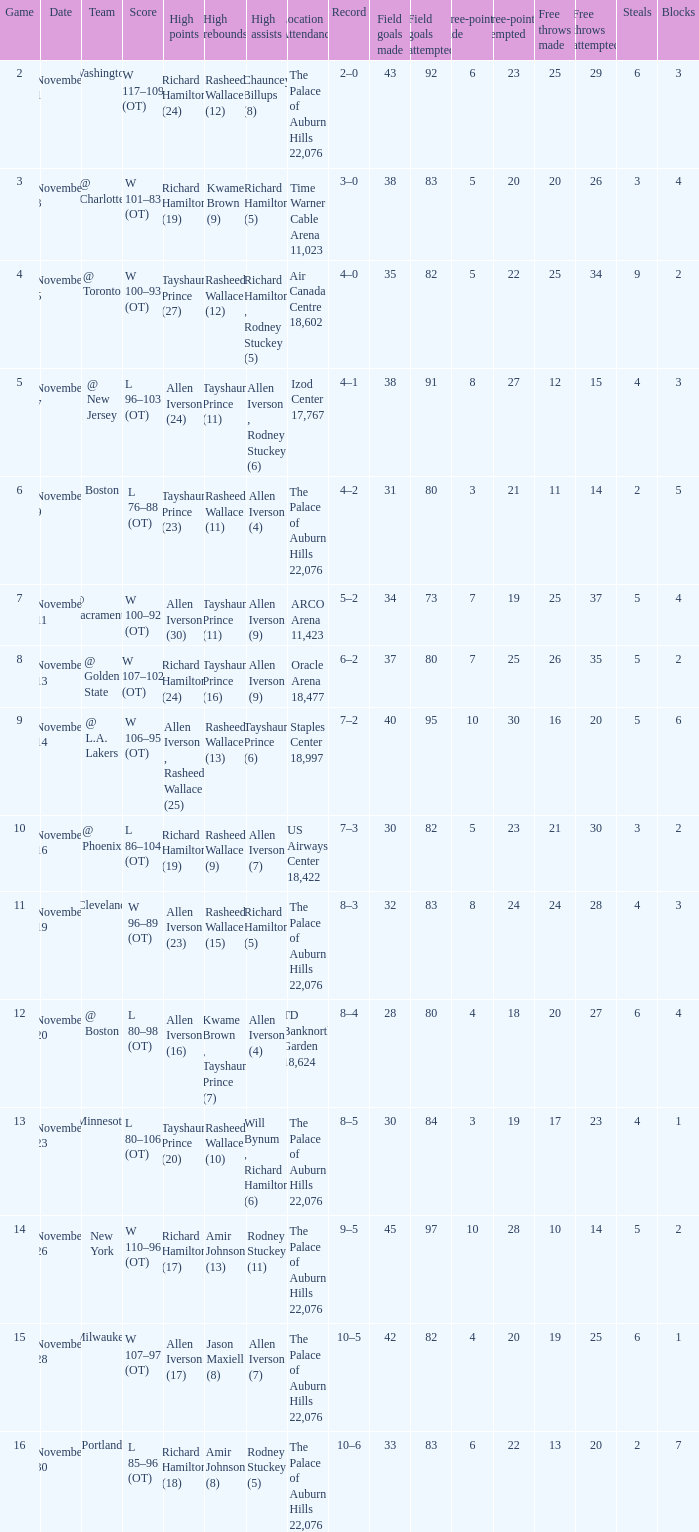What is the average Game, when Team is "Milwaukee"? 15.0. 